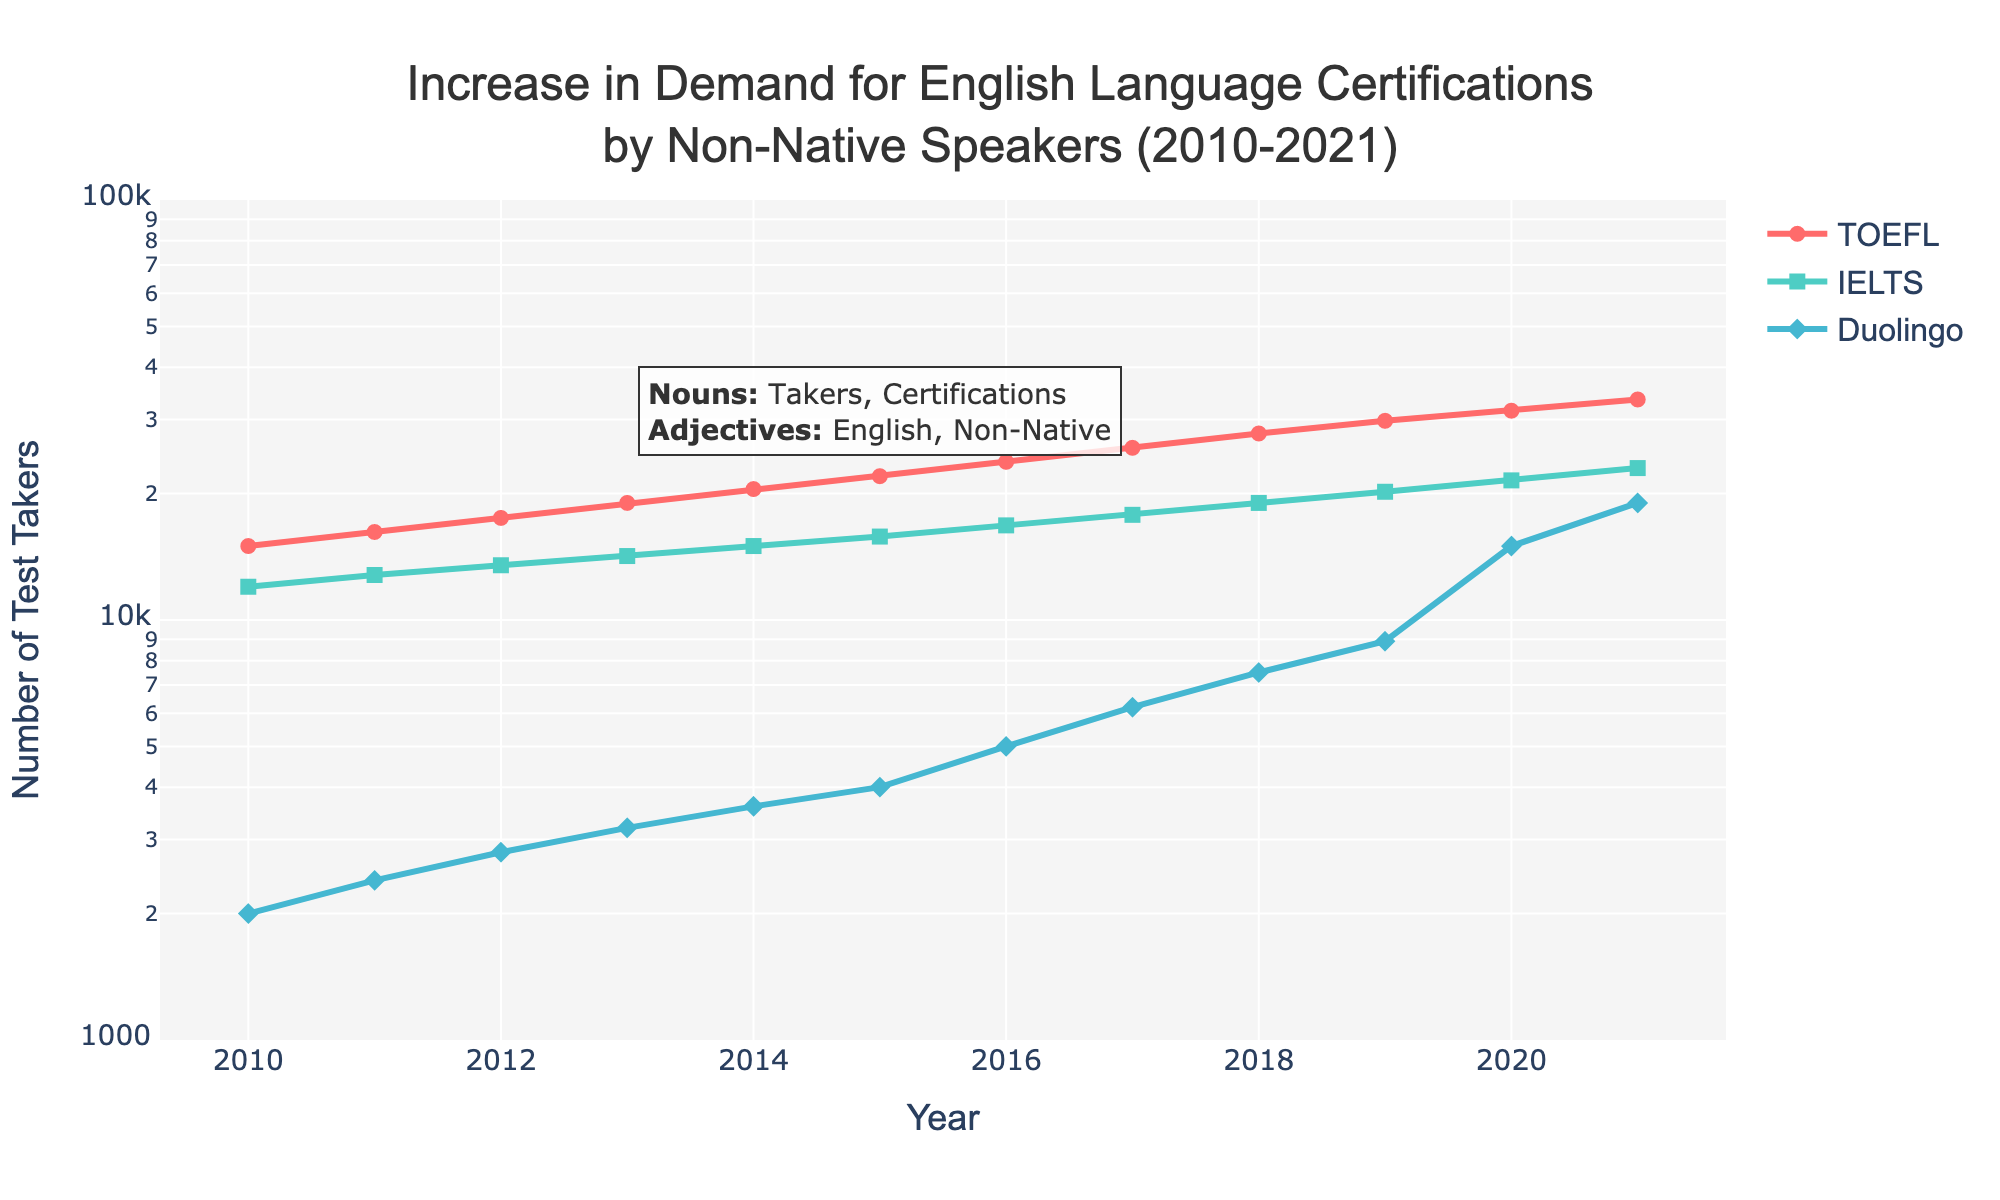What is the title of the plot? The title is located at the top center of the plot and describes the topic of the data being visualized.
Answer: Increase in Demand for English Language Certifications by Non-Native Speakers (2010-2021) Which line represents the number of TOEFL Takers? Lines are distinguished by different colors and markers. TOEFL is represented by a red line with circle markers based on the legend.
Answer: The red line with circle markers How many IELTS Takers were there in 2015? Locate the year 2015 on the x-axis, follow upwards to the green line, and read the y-axis value. Remember that the y-axis is in a log scale.
Answer: 15,800 Which certification saw the highest increase in the number of test takers from 2019 to 2020? Compare the increase of each line from 2019 to 2020. The blue line (Duolingo) shows a larger vertical rise than the others.
Answer: Duolingo By how many test takers did the number of TOEFL Takers increase from 2010 to 2021? Subtract the number of TOEFL Takers in 2010 from the number in 2021. 33,500 - 15,000 = 18,500
Answer: 18,500 How do the trends of TOEFL and IELTS compare from 2010 to 2021? Observe the red and green lines for TOEFL and IELTS respectively. Both lines show upward trends, but the TOEFL line has a slightly higher slope.
Answer: Both are increasing, TOEFL has a steeper slope In which year did Duolingo English Test Takers surpass 10,000? Find the point where the blue line (Duolingo) surpasses 10,000 (log scale equivalent is 4 on the y-axis).
Answer: 2020 What is the overall trend for the number of Duolingo English Test Takers from 2010 to 2021? The blue line shows a steady ascent, indicating a significant increase over the years.
Answer: Steadily increasing Which year had the smallest growth in IELTS Takers compared to the previous year? Identify years with minimal slope in the green line. Between 2016 to 2017 appears to be the smallest increase.
Answer: 2016 to 2017 